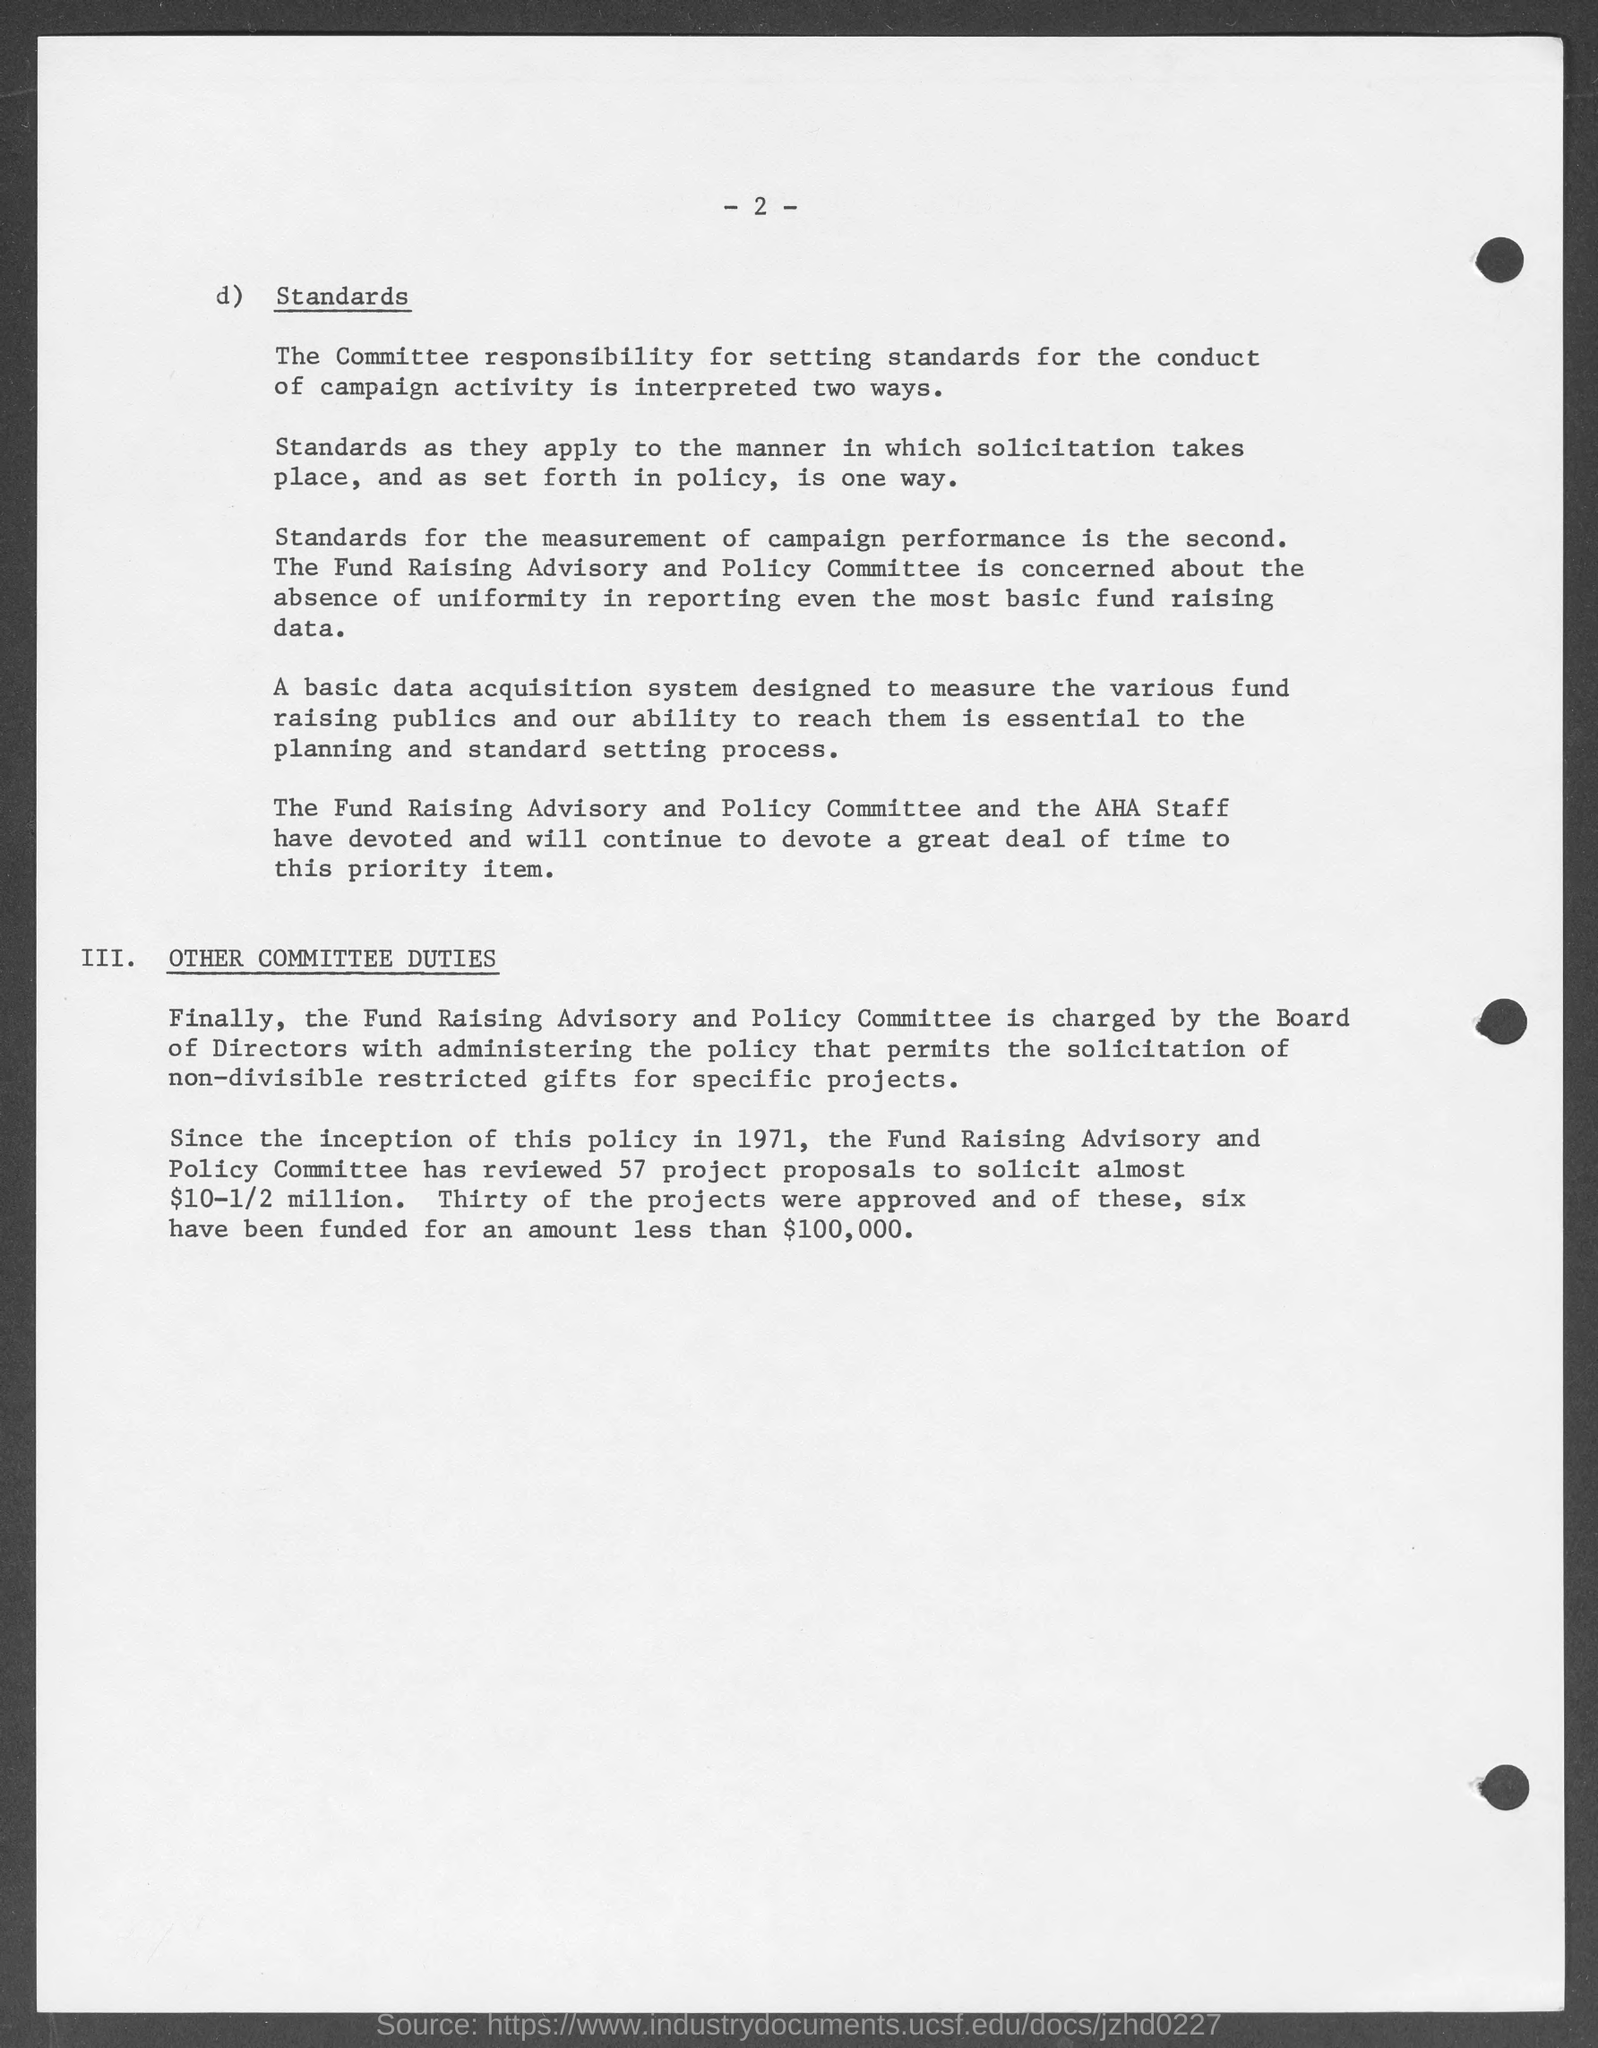Point out several critical features in this image. The page number mentioned in this document is 2. 